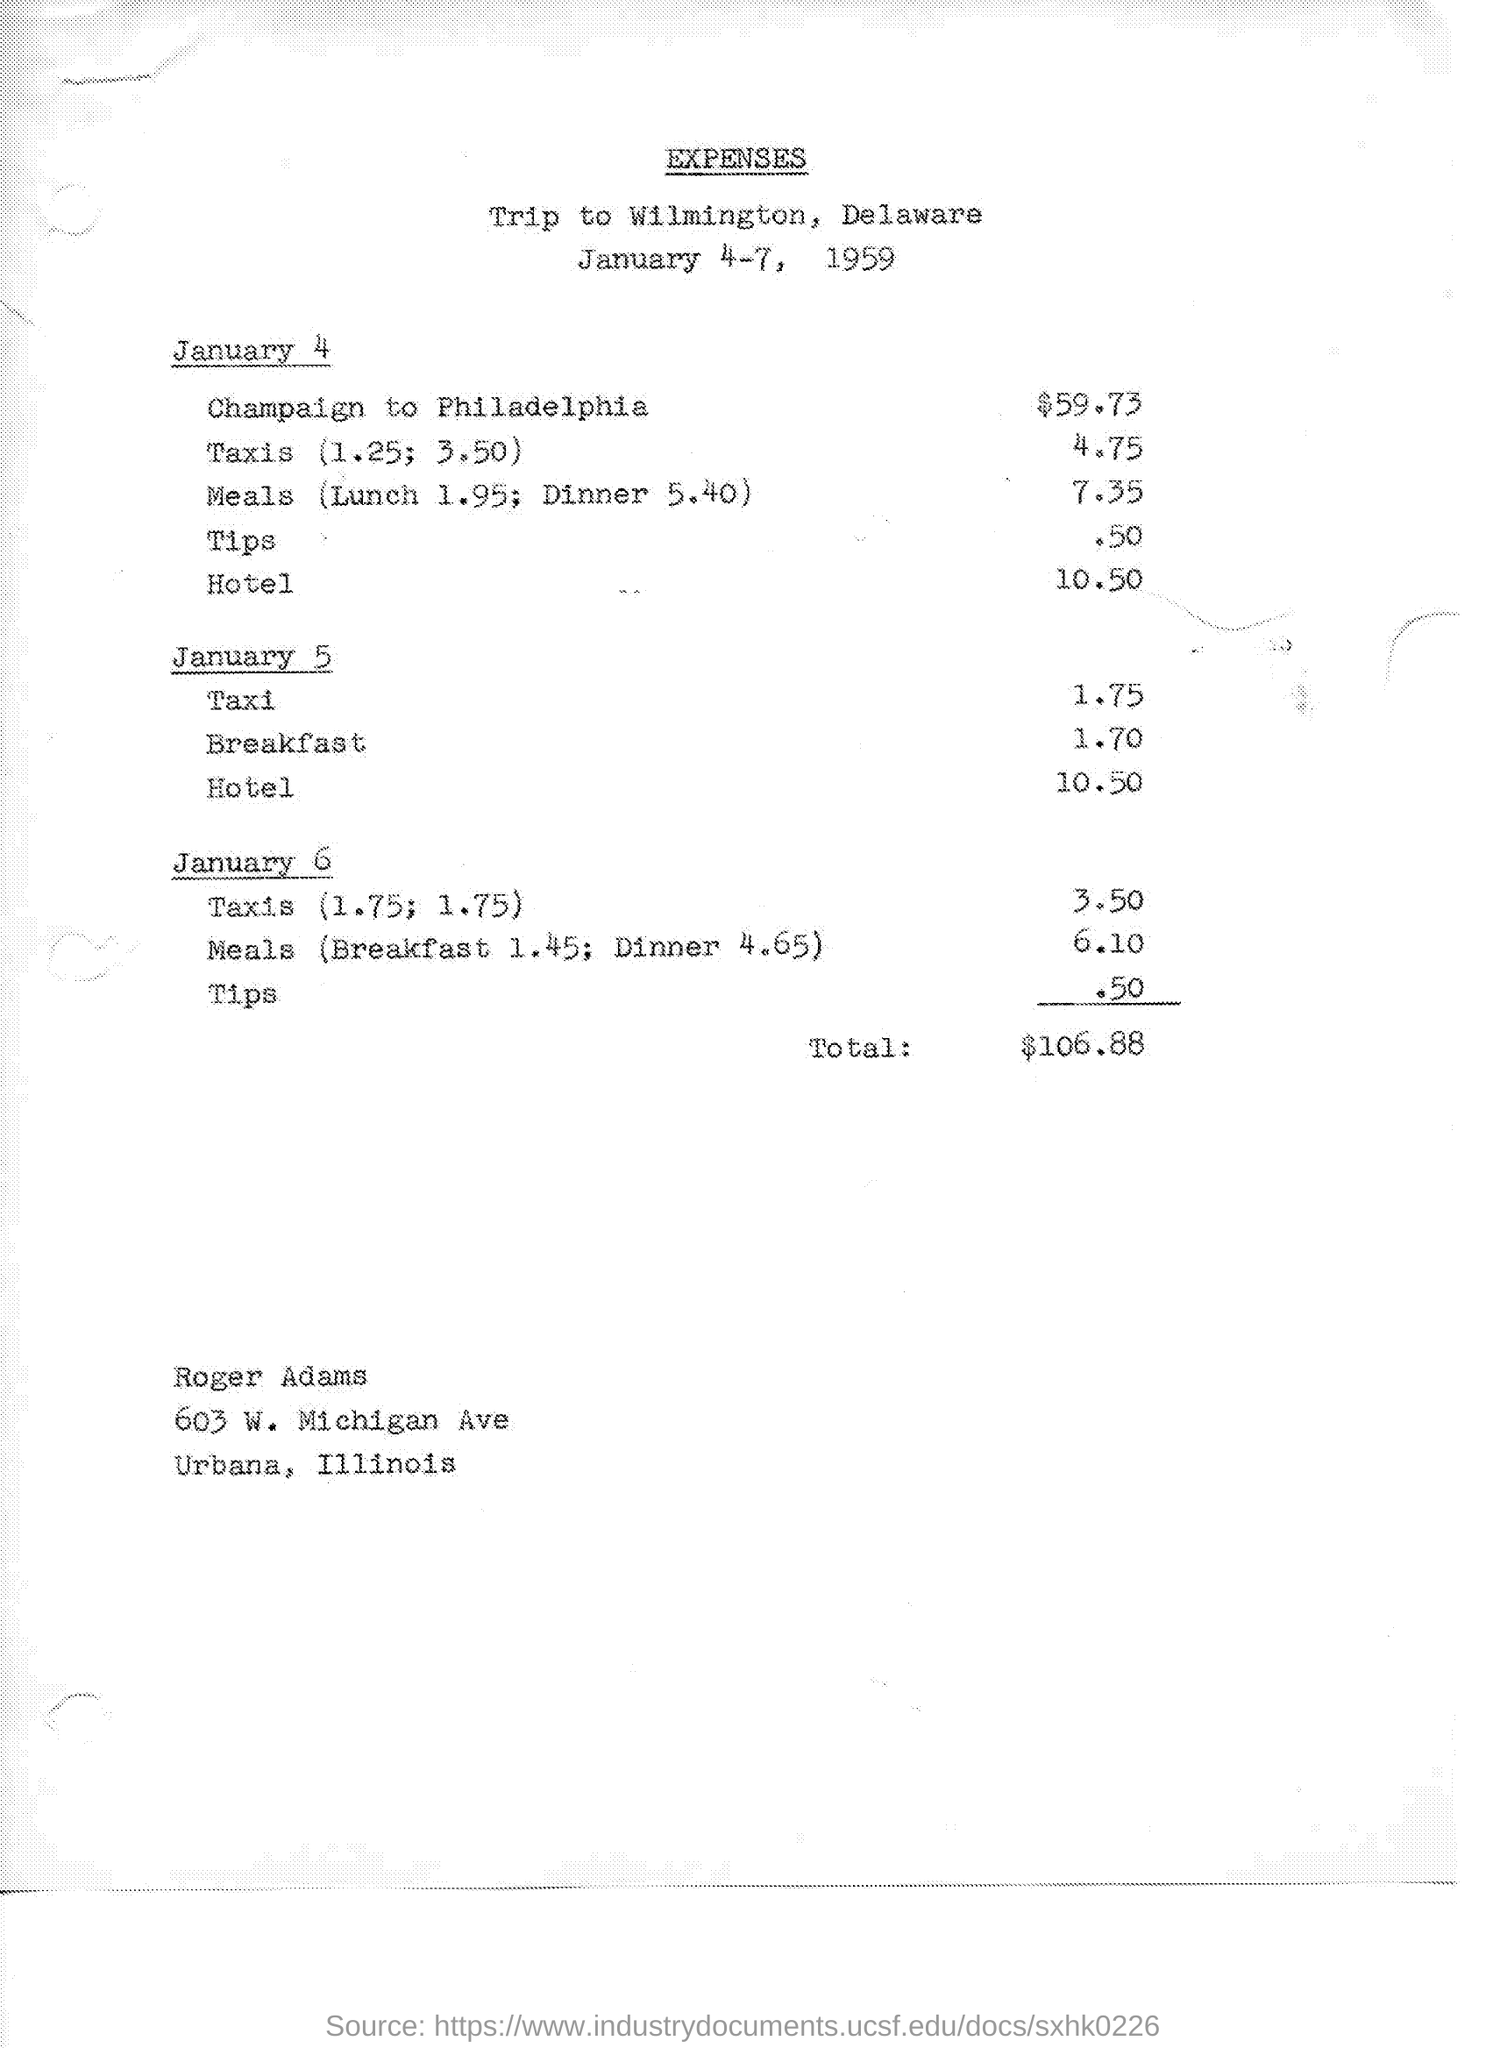What  is the cost for champaign to philadelphis on january 4 ?
Your answer should be very brief. $59.73. What is the cost for meals on january 4 ?
Offer a very short reply. 7.35. What is the cost of hotel on january 4 ?
Your answer should be very brief. 10.50. What is the cost of taxi on january 5 ?
Your answer should be compact. 1.75. What is the cost of breakfast on january 5 ?
Provide a short and direct response. 1.70. What is the cost of hotel on january 5 ?
Make the answer very short. 10.50. What is the cost of taxis on january 6 ?
Give a very brief answer. 3.50. What is the cost of meals on january 6 ?
Give a very brief answer. 6.10. What are the total expenses mentioned in the given page ?
Your response must be concise. $106.88. What is the cost of tips on january 6 ?
Offer a terse response. .50. 